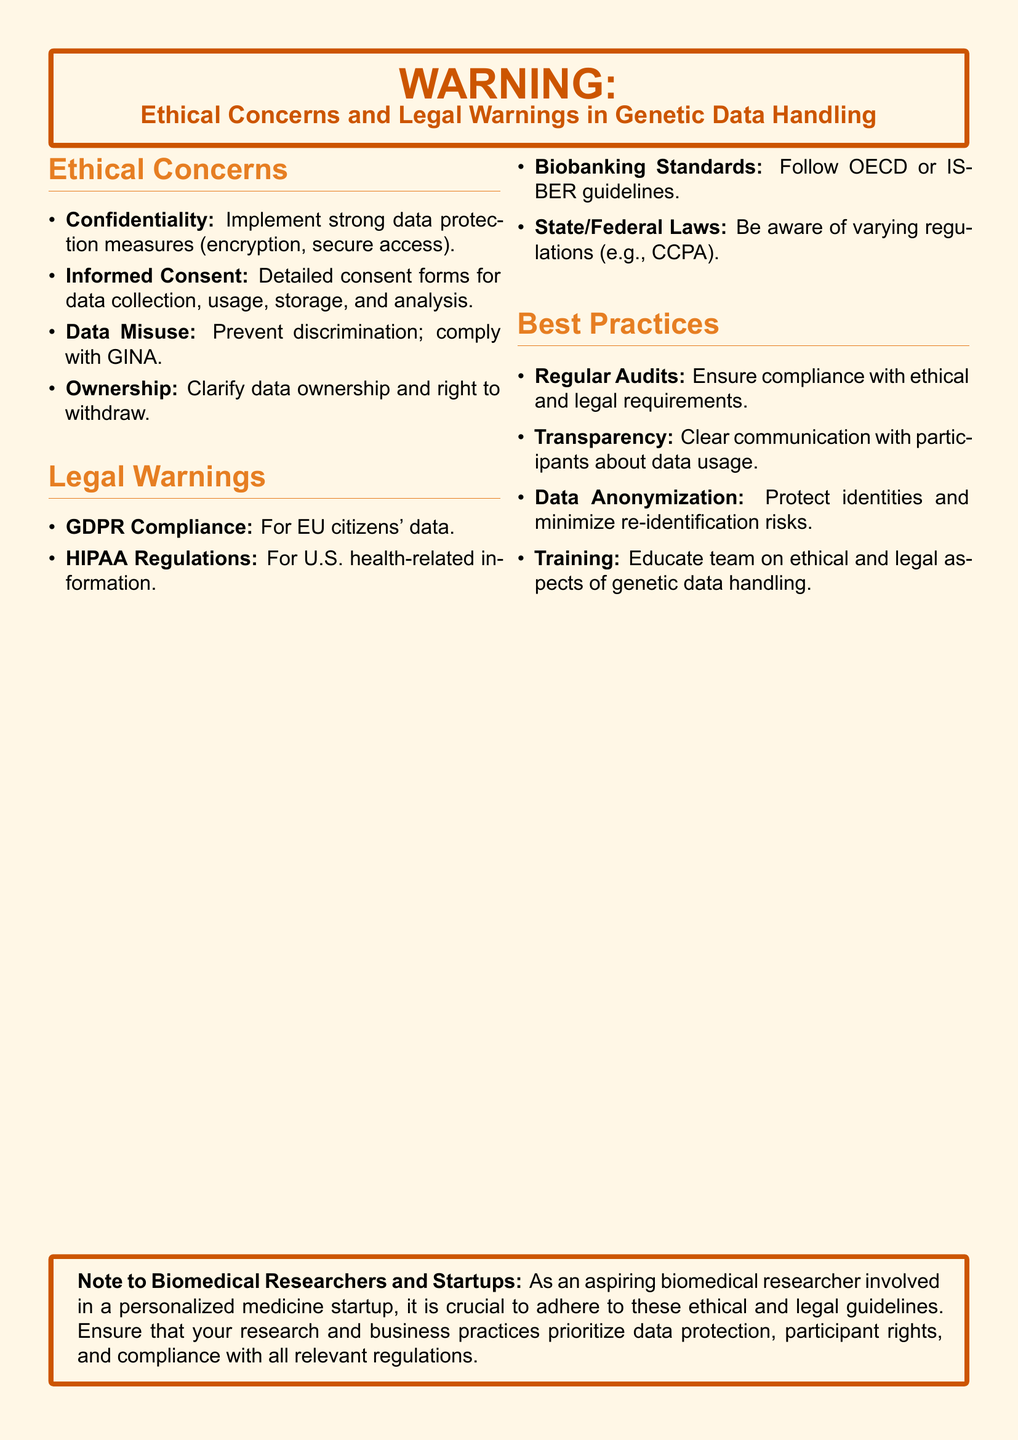What is a key ethical concern listed? The document mentions several key ethical concerns, including confidentiality, informed consent, and data misuse.
Answer: Confidentiality What regulation applies to U.S. health-related information? The document specifies that HIPAA regulations are relevant for health-related information in the U.S.
Answer: HIPAA Regulations What does GINA stand for? GINA is referenced in the context of preventing discrimination in genetic data handling. It stands for Genetic Information Nondiscrimination Act.
Answer: Genetic Information Nondiscrimination Act Which guideline is mentioned regarding biobanking standards? The document states that biobanking practices should adhere to certain established guidelines, specifically from OECD or ISBER.
Answer: OECD or ISBER What is the primary reason for having informed consent forms? The document highlights the importance of informed consent forms for addressing issues related to data collection, usage, and storage.
Answer: Data collection, usage, storage How often should audits be conducted according to best practices? The document suggests that regular audits are necessary to maintain compliance with ethical and legal requirements.
Answer: Regular What does GDPR apply to? The document specifies that GDPR compliance is necessary for handling the data of EU citizens.
Answer: EU citizens' data What is one of the best practices for protecting data? The document lists data anonymization as a recommended practice to minimize re-identification risks.
Answer: Data Anonymization Which color is used for the warning background? The document designates a specific RGB color for the background of the warning, which is described in the code settings as a warm light tone.
Answer: RGB(255,247,230) 